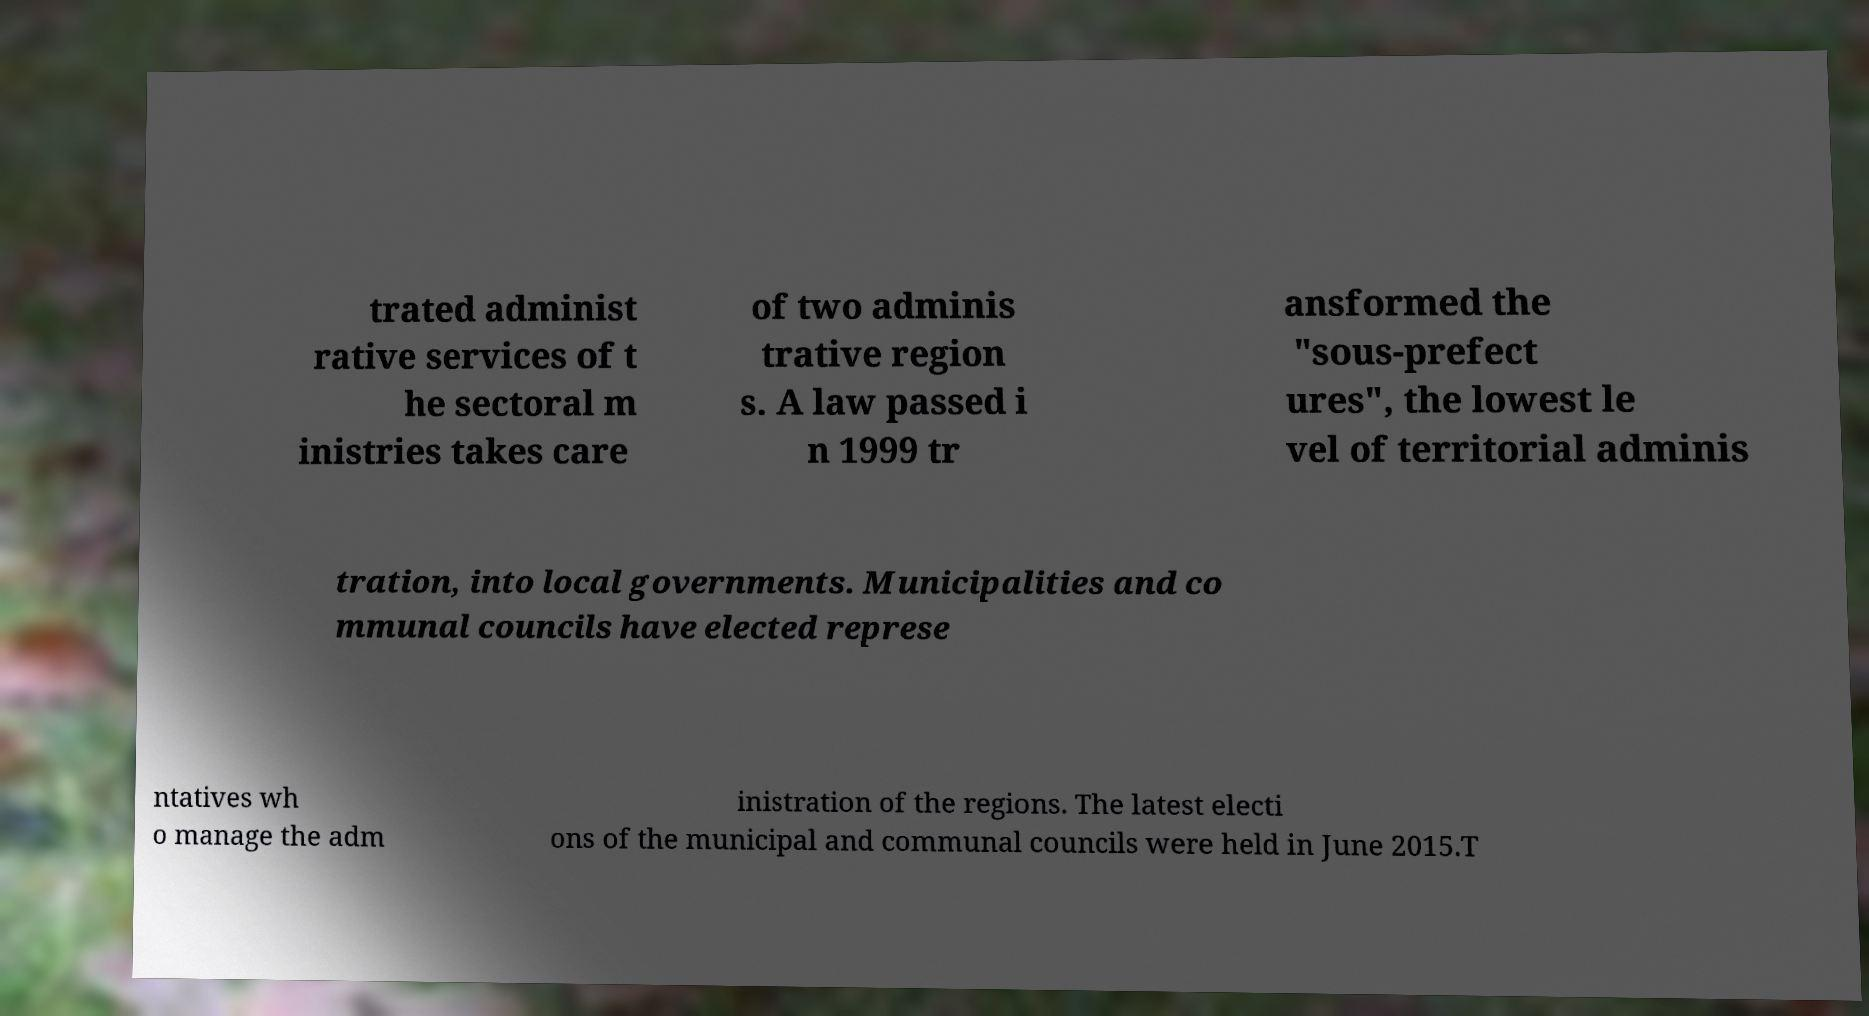Can you accurately transcribe the text from the provided image for me? trated administ rative services of t he sectoral m inistries takes care of two adminis trative region s. A law passed i n 1999 tr ansformed the "sous-prefect ures", the lowest le vel of territorial adminis tration, into local governments. Municipalities and co mmunal councils have elected represe ntatives wh o manage the adm inistration of the regions. The latest electi ons of the municipal and communal councils were held in June 2015.T 